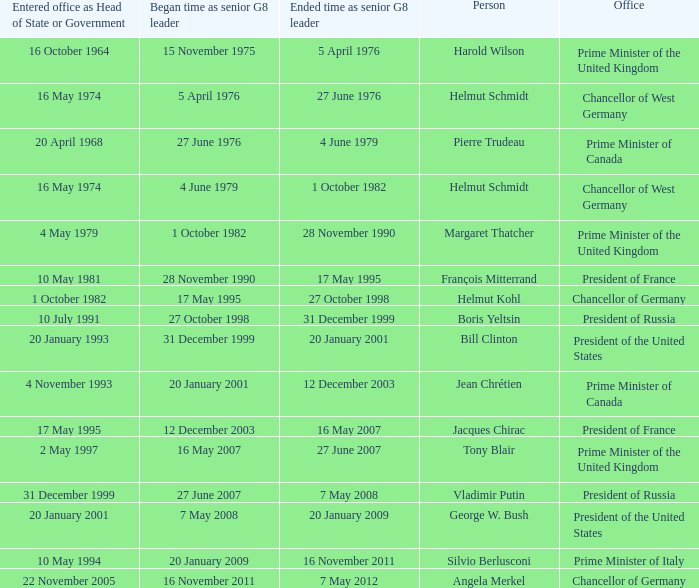When did the Prime Minister of Italy take office? 10 May 1994. 